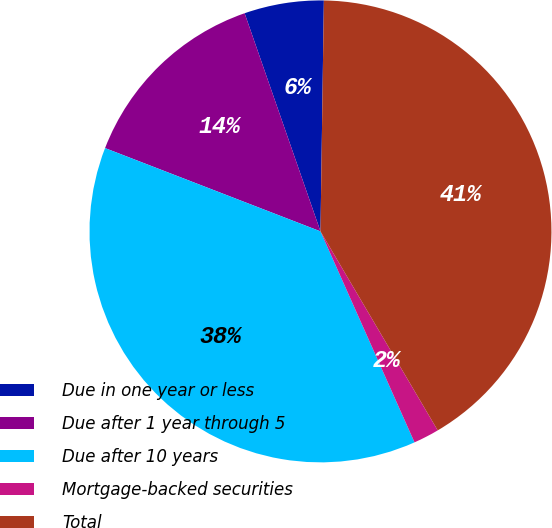Convert chart to OTSL. <chart><loc_0><loc_0><loc_500><loc_500><pie_chart><fcel>Due in one year or less<fcel>Due after 1 year through 5<fcel>Due after 10 years<fcel>Mortgage-backed securities<fcel>Total<nl><fcel>5.56%<fcel>13.8%<fcel>37.54%<fcel>1.8%<fcel>41.29%<nl></chart> 